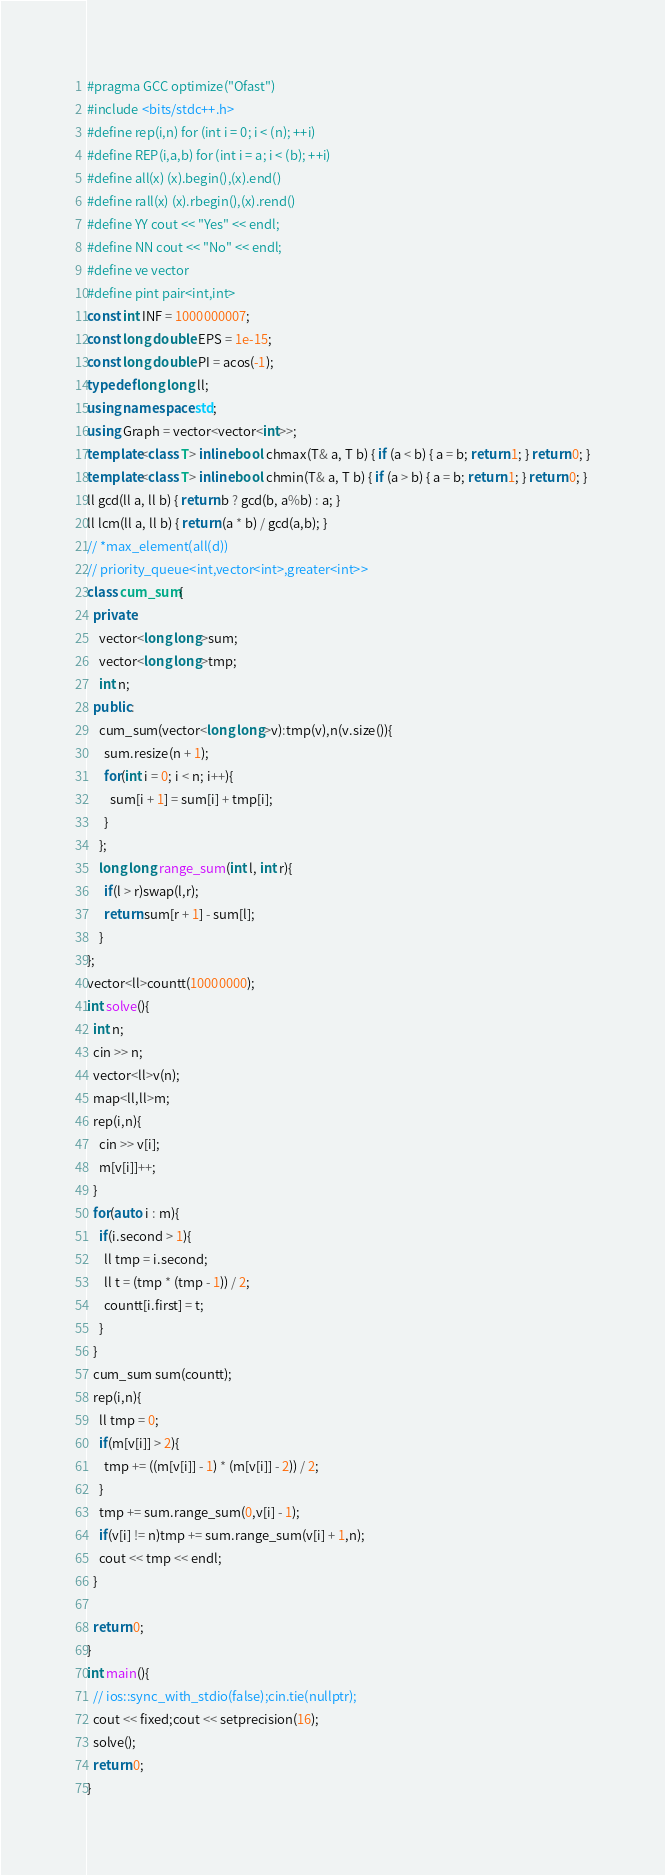<code> <loc_0><loc_0><loc_500><loc_500><_C++_>#pragma GCC optimize("Ofast")
#include <bits/stdc++.h>
#define rep(i,n) for (int i = 0; i < (n); ++i)
#define REP(i,a,b) for (int i = a; i < (b); ++i)
#define all(x) (x).begin(),(x).end()
#define rall(x) (x).rbegin(),(x).rend()
#define YY cout << "Yes" << endl;
#define NN cout << "No" << endl;
#define ve vector
#define pint pair<int,int>
const int INF = 1000000007;
const long double EPS = 1e-15;
const long double PI = acos(-1);
typedef long long ll;
using namespace std;
using Graph = vector<vector<int>>;
template<class T> inline bool chmax(T& a, T b) { if (a < b) { a = b; return 1; } return 0; }
template<class T> inline bool chmin(T& a, T b) { if (a > b) { a = b; return 1; } return 0; }
ll gcd(ll a, ll b) { return b ? gcd(b, a%b) : a; }
ll lcm(ll a, ll b) { return (a * b) / gcd(a,b); }
// *max_element(all(d))
// priority_queue<int,vector<int>,greater<int>>
class cum_sum{
  private:
    vector<long long>sum;
    vector<long long>tmp;
    int n;
  public:
    cum_sum(vector<long long>v):tmp(v),n(v.size()){
      sum.resize(n + 1);
      for(int i = 0; i < n; i++){
        sum[i + 1] = sum[i] + tmp[i];
      }
    };
    long long range_sum(int l, int r){
      if(l > r)swap(l,r);
      return sum[r + 1] - sum[l];
    }
}; 
vector<ll>countt(10000000);
int solve(){
  int n;
  cin >> n;
  vector<ll>v(n);
  map<ll,ll>m;
  rep(i,n){
    cin >> v[i];
    m[v[i]]++;
  }
  for(auto i : m){
    if(i.second > 1){
      ll tmp = i.second;
      ll t = (tmp * (tmp - 1)) / 2;
      countt[i.first] = t;
    }
  }
  cum_sum sum(countt);
  rep(i,n){
    ll tmp = 0;
    if(m[v[i]] > 2){
      tmp += ((m[v[i]] - 1) * (m[v[i]] - 2)) / 2;
    }
    tmp += sum.range_sum(0,v[i] - 1);
    if(v[i] != n)tmp += sum.range_sum(v[i] + 1,n);
    cout << tmp << endl;
  }

  return 0; 
}
int main(){
  // ios::sync_with_stdio(false);cin.tie(nullptr);
  cout << fixed;cout << setprecision(16);
  solve();
  return 0;
}</code> 